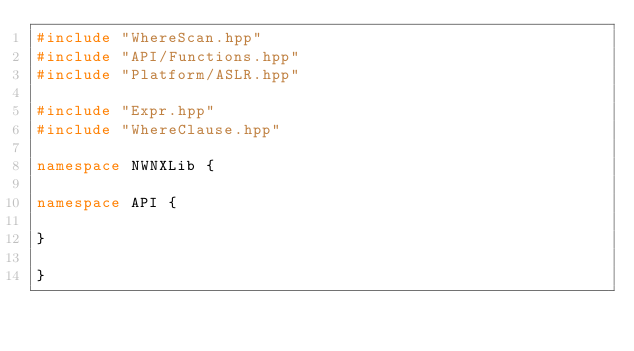<code> <loc_0><loc_0><loc_500><loc_500><_C++_>#include "WhereScan.hpp"
#include "API/Functions.hpp"
#include "Platform/ASLR.hpp"

#include "Expr.hpp"
#include "WhereClause.hpp"

namespace NWNXLib {

namespace API {

}

}
</code> 